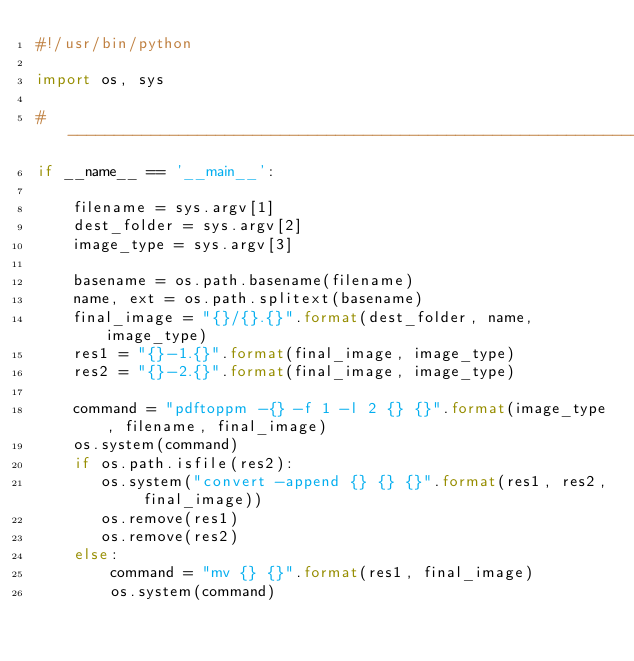<code> <loc_0><loc_0><loc_500><loc_500><_Python_>#!/usr/bin/python

import os, sys

#-----------------------------------------------------------------------
if __name__ == '__main__':

    filename = sys.argv[1]
    dest_folder = sys.argv[2]
    image_type = sys.argv[3]

    basename = os.path.basename(filename)
    name, ext = os.path.splitext(basename)
    final_image = "{}/{}.{}".format(dest_folder, name, image_type)
    res1 = "{}-1.{}".format(final_image, image_type)
    res2 = "{}-2.{}".format(final_image, image_type)
    
    command = "pdftoppm -{} -f 1 -l 2 {} {}".format(image_type, filename, final_image)
    os.system(command)
    if os.path.isfile(res2):
       os.system("convert -append {} {} {}".format(res1, res2, final_image))
       os.remove(res1)
       os.remove(res2)
    else:
        command = "mv {} {}".format(res1, final_image)
        os.system(command)

</code> 